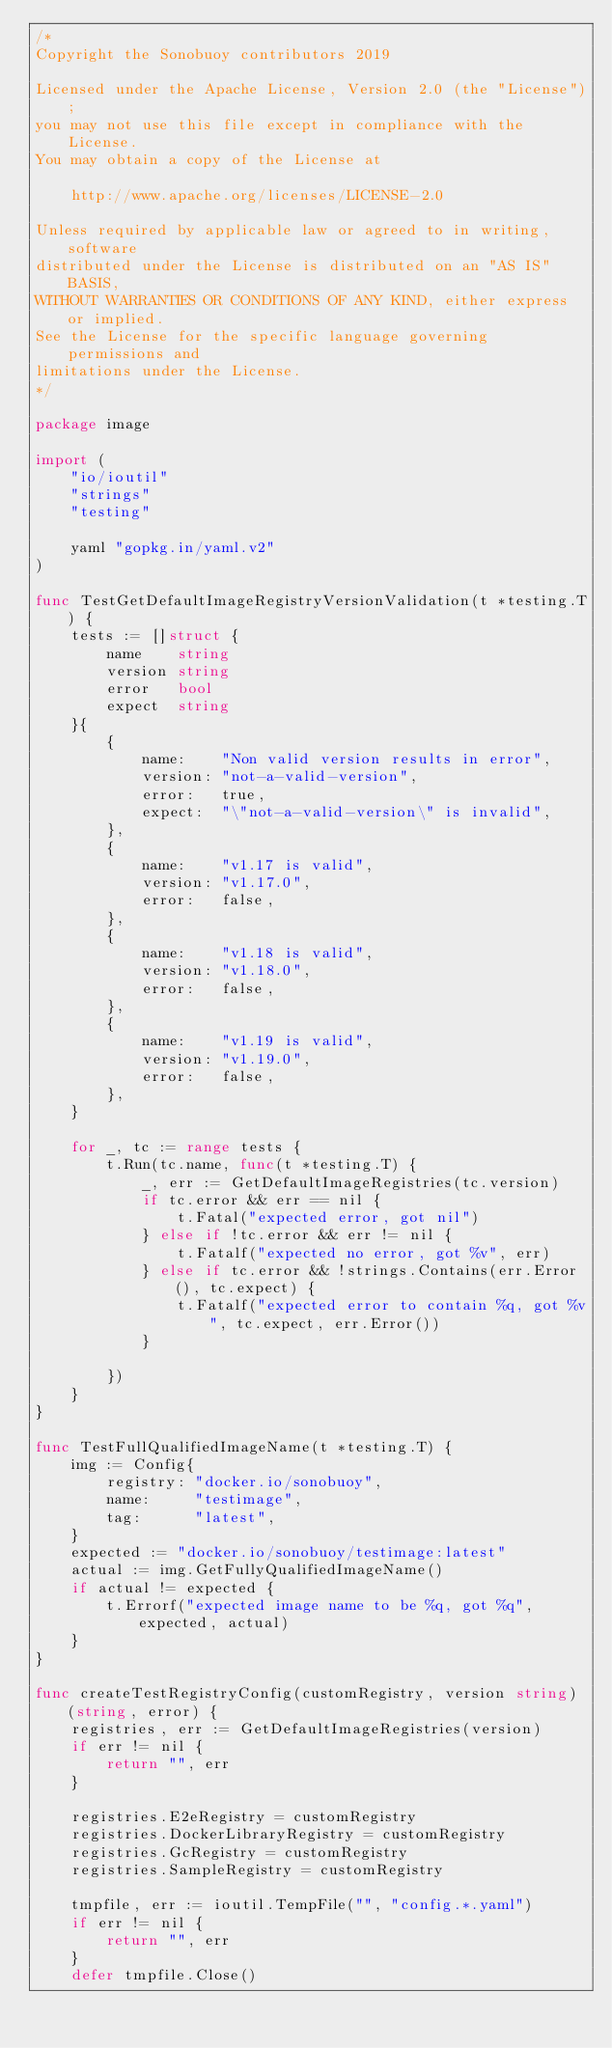<code> <loc_0><loc_0><loc_500><loc_500><_Go_>/*
Copyright the Sonobuoy contributors 2019

Licensed under the Apache License, Version 2.0 (the "License");
you may not use this file except in compliance with the License.
You may obtain a copy of the License at

    http://www.apache.org/licenses/LICENSE-2.0

Unless required by applicable law or agreed to in writing, software
distributed under the License is distributed on an "AS IS" BASIS,
WITHOUT WARRANTIES OR CONDITIONS OF ANY KIND, either express or implied.
See the License for the specific language governing permissions and
limitations under the License.
*/

package image

import (
	"io/ioutil"
	"strings"
	"testing"

	yaml "gopkg.in/yaml.v2"
)

func TestGetDefaultImageRegistryVersionValidation(t *testing.T) {
	tests := []struct {
		name    string
		version string
		error   bool
		expect  string
	}{
		{
			name:    "Non valid version results in error",
			version: "not-a-valid-version",
			error:   true,
			expect:  "\"not-a-valid-version\" is invalid",
		},
		{
			name:    "v1.17 is valid",
			version: "v1.17.0",
			error:   false,
		},
		{
			name:    "v1.18 is valid",
			version: "v1.18.0",
			error:   false,
		},
		{
			name:    "v1.19 is valid",
			version: "v1.19.0",
			error:   false,
		},
	}

	for _, tc := range tests {
		t.Run(tc.name, func(t *testing.T) {
			_, err := GetDefaultImageRegistries(tc.version)
			if tc.error && err == nil {
				t.Fatal("expected error, got nil")
			} else if !tc.error && err != nil {
				t.Fatalf("expected no error, got %v", err)
			} else if tc.error && !strings.Contains(err.Error(), tc.expect) {
				t.Fatalf("expected error to contain %q, got %v", tc.expect, err.Error())
			}

		})
	}
}

func TestFullQualifiedImageName(t *testing.T) {
	img := Config{
		registry: "docker.io/sonobuoy",
		name:     "testimage",
		tag:      "latest",
	}
	expected := "docker.io/sonobuoy/testimage:latest"
	actual := img.GetFullyQualifiedImageName()
	if actual != expected {
		t.Errorf("expected image name to be %q, got %q", expected, actual)
	}
}

func createTestRegistryConfig(customRegistry, version string) (string, error) {
	registries, err := GetDefaultImageRegistries(version)
	if err != nil {
		return "", err
	}

	registries.E2eRegistry = customRegistry
	registries.DockerLibraryRegistry = customRegistry
	registries.GcRegistry = customRegistry
	registries.SampleRegistry = customRegistry

	tmpfile, err := ioutil.TempFile("", "config.*.yaml")
	if err != nil {
		return "", err
	}
	defer tmpfile.Close()
</code> 